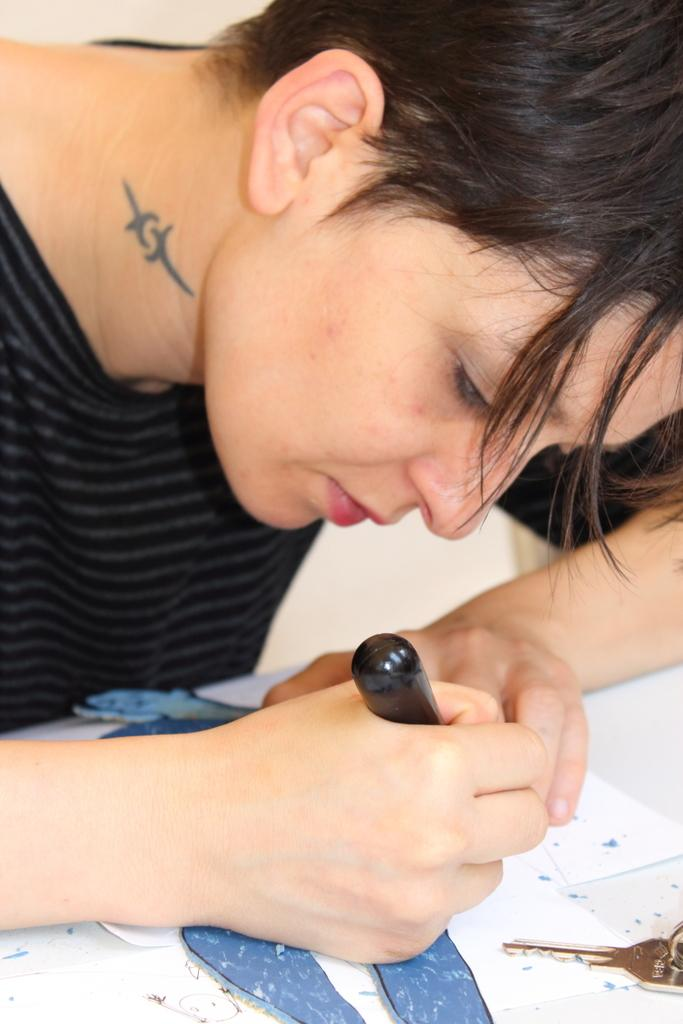What is the person in the image holding? The person is holding an object in the image. What else can be seen in the image besides the person? There are papers and a key in the image. What is the color of the background in the image? The background of the image is white. What type of quilt is being used topped by the tank in the image? There is no quilt or tank present in the image; the background is white, and the main subjects are a person holding an object, papers, and a key. 